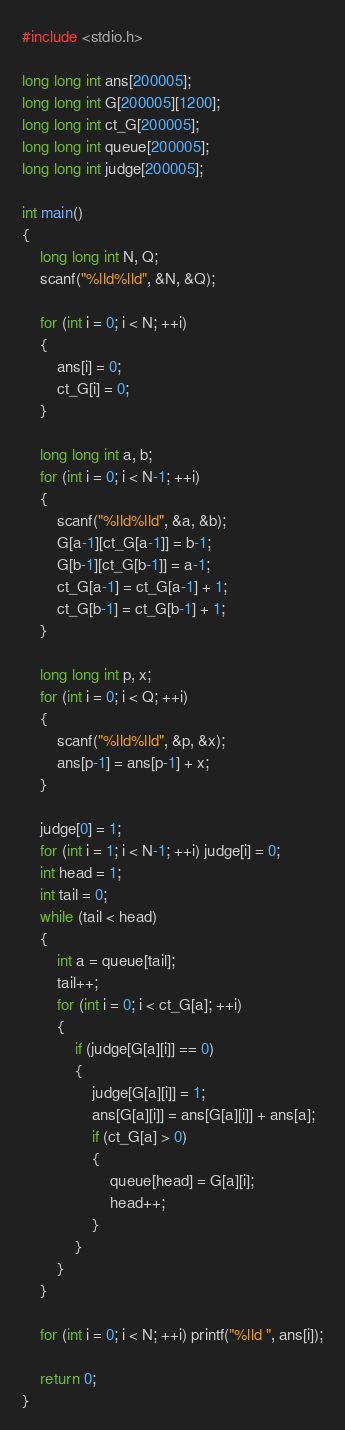<code> <loc_0><loc_0><loc_500><loc_500><_C_>#include <stdio.h>

long long int ans[200005];
long long int G[200005][1200];
long long int ct_G[200005];
long long int queue[200005];
long long int judge[200005];

int main()
{
    long long int N, Q;
    scanf("%lld%lld", &N, &Q);

    for (int i = 0; i < N; ++i)
    {
        ans[i] = 0;
        ct_G[i] = 0;
    }

    long long int a, b;
    for (int i = 0; i < N-1; ++i)
    {
        scanf("%lld%lld", &a, &b);
        G[a-1][ct_G[a-1]] = b-1;
        G[b-1][ct_G[b-1]] = a-1;
        ct_G[a-1] = ct_G[a-1] + 1;
        ct_G[b-1] = ct_G[b-1] + 1;
    }

    long long int p, x;
    for (int i = 0; i < Q; ++i)
    {
        scanf("%lld%lld", &p, &x);
        ans[p-1] = ans[p-1] + x;
    }

    judge[0] = 1;
    for (int i = 1; i < N-1; ++i) judge[i] = 0;
    int head = 1;
    int tail = 0;
    while (tail < head)
    {
        int a = queue[tail];
        tail++;
        for (int i = 0; i < ct_G[a]; ++i)
        {
            if (judge[G[a][i]] == 0)
            {
                judge[G[a][i]] = 1;
                ans[G[a][i]] = ans[G[a][i]] + ans[a];
                if (ct_G[a] > 0)
                {
                    queue[head] = G[a][i];
                    head++;
                }
            }
        }
    }

    for (int i = 0; i < N; ++i) printf("%lld ", ans[i]);

    return 0;
}
</code> 